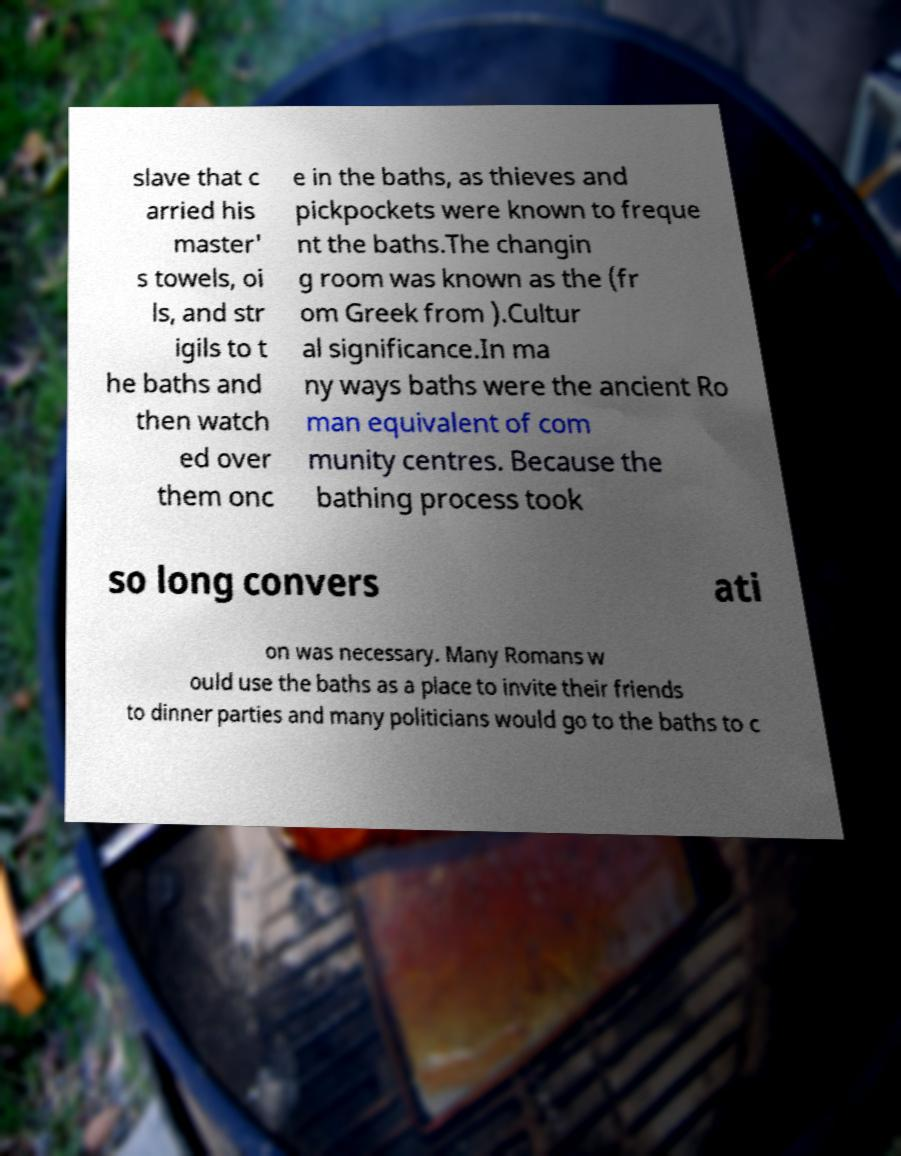I need the written content from this picture converted into text. Can you do that? slave that c arried his master' s towels, oi ls, and str igils to t he baths and then watch ed over them onc e in the baths, as thieves and pickpockets were known to freque nt the baths.The changin g room was known as the (fr om Greek from ).Cultur al significance.In ma ny ways baths were the ancient Ro man equivalent of com munity centres. Because the bathing process took so long convers ati on was necessary. Many Romans w ould use the baths as a place to invite their friends to dinner parties and many politicians would go to the baths to c 